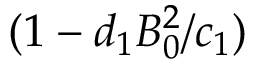<formula> <loc_0><loc_0><loc_500><loc_500>( 1 - d _ { 1 } B _ { 0 } ^ { 2 } / c _ { 1 } )</formula> 